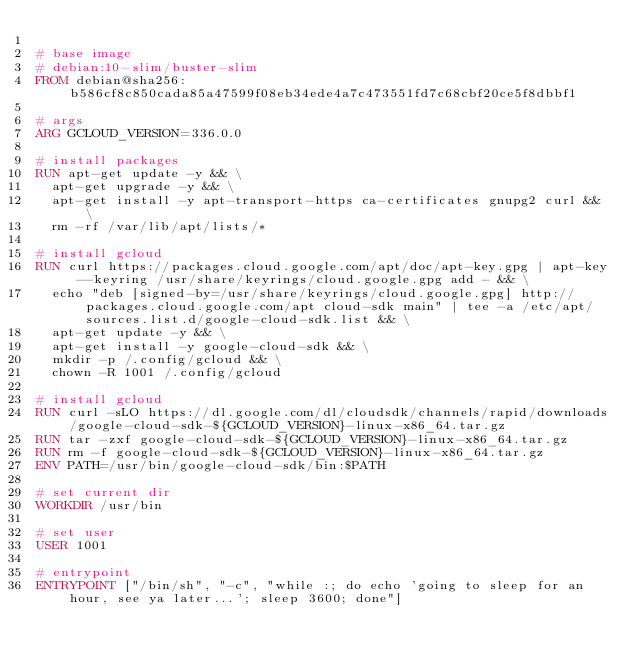<code> <loc_0><loc_0><loc_500><loc_500><_Dockerfile_>
# base image
# debian:10-slim/buster-slim
FROM debian@sha256:b586cf8c850cada85a47599f08eb34ede4a7c473551fd7c68cbf20ce5f8dbbf1

# args
ARG GCLOUD_VERSION=336.0.0

# install packages
RUN apt-get update -y && \
	apt-get upgrade -y && \
	apt-get install -y apt-transport-https ca-certificates gnupg2 curl && \
	rm -rf /var/lib/apt/lists/*

# install gcloud
RUN curl https://packages.cloud.google.com/apt/doc/apt-key.gpg | apt-key --keyring /usr/share/keyrings/cloud.google.gpg add - && \
	echo "deb [signed-by=/usr/share/keyrings/cloud.google.gpg] http://packages.cloud.google.com/apt cloud-sdk main" | tee -a /etc/apt/sources.list.d/google-cloud-sdk.list && \
	apt-get update -y && \
	apt-get install -y google-cloud-sdk && \
	mkdir -p /.config/gcloud && \
	chown -R 1001 /.config/gcloud

# install gcloud
RUN curl -sLO https://dl.google.com/dl/cloudsdk/channels/rapid/downloads/google-cloud-sdk-${GCLOUD_VERSION}-linux-x86_64.tar.gz
RUN tar -zxf google-cloud-sdk-${GCLOUD_VERSION}-linux-x86_64.tar.gz
RUN rm -f google-cloud-sdk-${GCLOUD_VERSION}-linux-x86_64.tar.gz
ENV PATH=/usr/bin/google-cloud-sdk/bin:$PATH

# set current dir
WORKDIR /usr/bin

# set user
USER 1001

# entrypoint
ENTRYPOINT ["/bin/sh", "-c", "while :; do echo 'going to sleep for an hour, see ya later...'; sleep 3600; done"]
</code> 